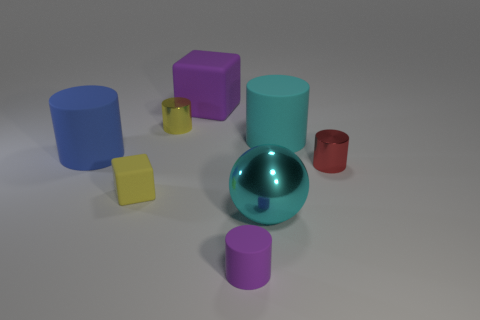What is the shape of the small purple thing?
Provide a short and direct response. Cylinder. There is a cyan ball that is the same size as the blue matte cylinder; what is it made of?
Give a very brief answer. Metal. What number of things are cyan shiny things or objects that are in front of the small yellow cube?
Keep it short and to the point. 2. There is a blue cylinder that is the same material as the large purple thing; what size is it?
Provide a succinct answer. Large. What shape is the thing behind the small yellow thing behind the big blue rubber cylinder?
Your answer should be compact. Cube. What size is the matte cylinder that is both to the left of the metal sphere and right of the large blue matte cylinder?
Ensure brevity in your answer.  Small. Is there another small purple object of the same shape as the small purple thing?
Offer a very short reply. No. Is there anything else that is the same shape as the cyan metallic object?
Provide a succinct answer. No. The block left of the yellow object that is behind the metal cylinder right of the purple rubber cylinder is made of what material?
Make the answer very short. Rubber. Are there any yellow shiny objects of the same size as the sphere?
Provide a succinct answer. No. 